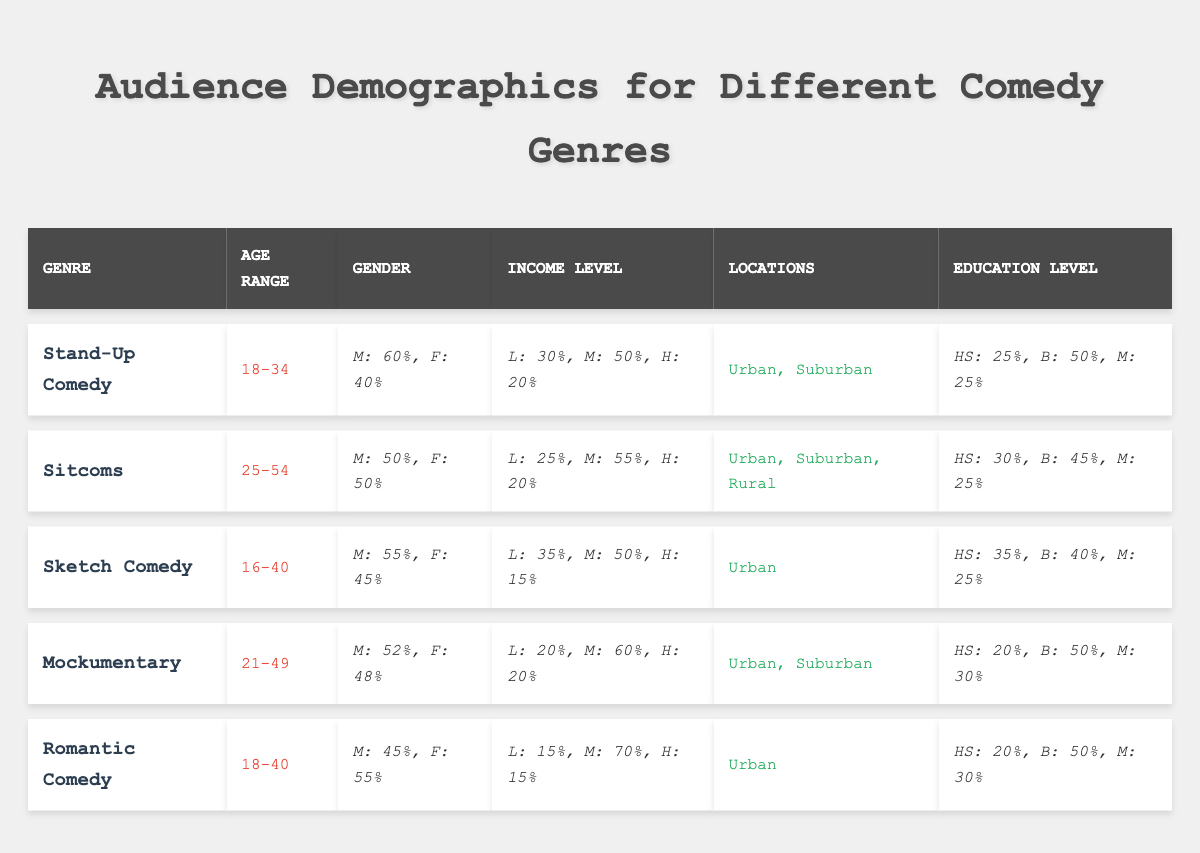What is the age range for Stand-Up Comedy? The age range for Stand-Up Comedy is listed in the table under the corresponding genre, showing it as 18-34.
Answer: 18-34 Which comedy genre has the highest percentage of male audience? Stand-Up Comedy has the highest male audience percentage at 60% compared to other genres, as indicated in the gender breakdown column.
Answer: Stand-Up Comedy How does the education level of Sketch Comedy audience compare to that of Sitcoms? In Sketch Comedy, the education level percentages are listed as 35% High School, 40% Bachelors, and 25% Masters. For Sitcoms, they are 30% High School, 45% Bachelors, and 25% Masters. Sketch Comedy has a higher percentage of High School graduates, while Sitcoms have more Bachelors.
Answer: Sketch Comedy has more High School, Sitcoms have more Bachelors What is the total percentage of low-income viewers for Mockumentary and Romantic Comedy? For Mockumentary, the low-income percentage is 20% and for Romantic Comedy, it is 15%. Adding them gives 20% + 15% = 35%.
Answer: 35% Is the audience for Sitcoms predominantly male? The gender breakdown for Sitcoms shows equal distribution with 50% male and 50% female, indicating that the audience is not predominantly male.
Answer: No Which genre has the largest age range? Analyzing the age ranges, Sketch Comedy spans from 16-40, the smallest range, while Sitcoms span from 25-54, which is the largest. Hence, Sitcoms have the largest age range.
Answer: Sitcoms What is the average percentage of middle-income viewers across all genres? The middle-income percentages for each genre are 50% (Stand-Up), 55% (Sitcoms), 50% (Sketch), 60% (Mockumentary), and 70% (Romantic). Adding them gives 285%, and dividing by 5 genres results in an average of 57%.
Answer: 57% Do all comedy genres have an audience in urban locations? Reviewing the locations for each genre, Stand-Up Comedy, Sketch Comedy, Mockumentary, and Romantic Comedy are listed as Urban, and Sitcoms include Rural as well, confirming that not all genres are exclusively Urban.
Answer: No What percentage of the audience for Romantic Comedy has a Bachelor's degree? The table shows that the Education Level for Romantic Comedy states that 50% of the audience holds a Bachelor's degree.
Answer: 50% How does the gender split compare for Stand-Up Comedy and Mockumentary? Stand-Up Comedy shows a 60% male and 40% female split while Mockumentary indicates a 52% male and 48% female split, demonstrating that Stand-Up Comedy has a slightly higher male audience percentage.
Answer: Stand-Up Comedy has a higher male percentage 